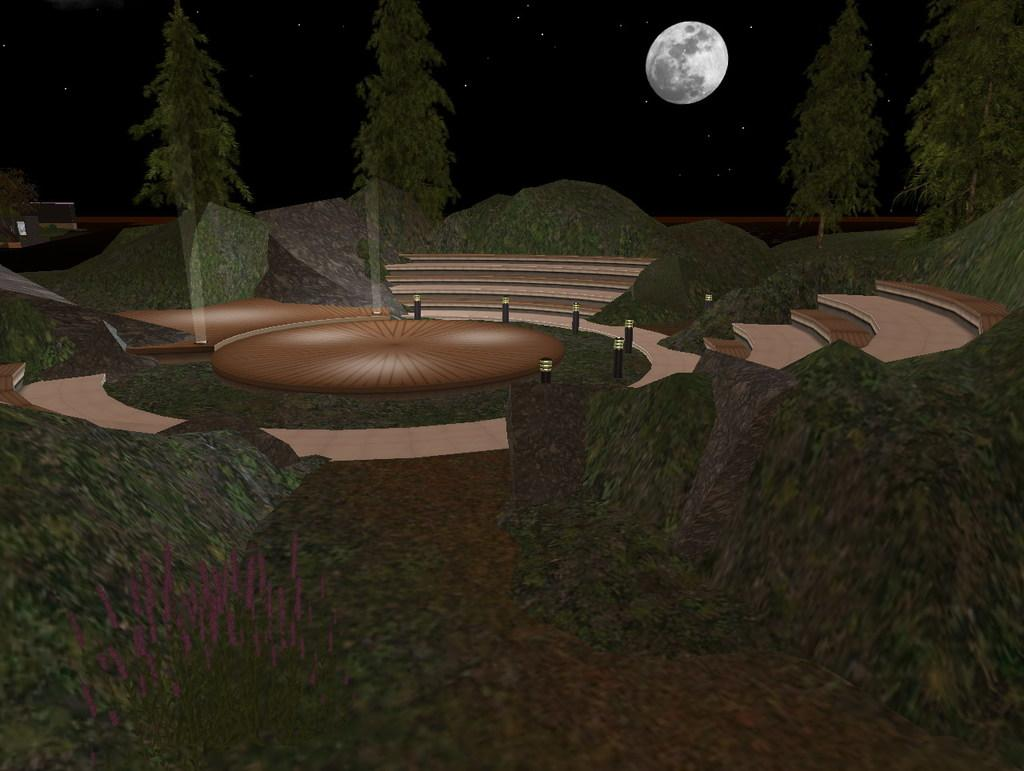What structures are present in the image? There are poles and steps in the image. What type of natural elements can be seen in the image? There are rocks and trees in the image. Are there any objects visible in the image? Yes, there are some objects in the image. What celestial body is visible in the background of the image? The moon is visible in the background of the image. How would you describe the lighting in the image? The background of the image is dark. Can you see any ants crawling on the rocks in the image? There are no ants visible in the image; it only shows poles, steps, rocks, trees, objects, the moon, and a dark background. Is there any poison present in the image? There is no mention of poison in the image, and it is not visible in the provided facts. 